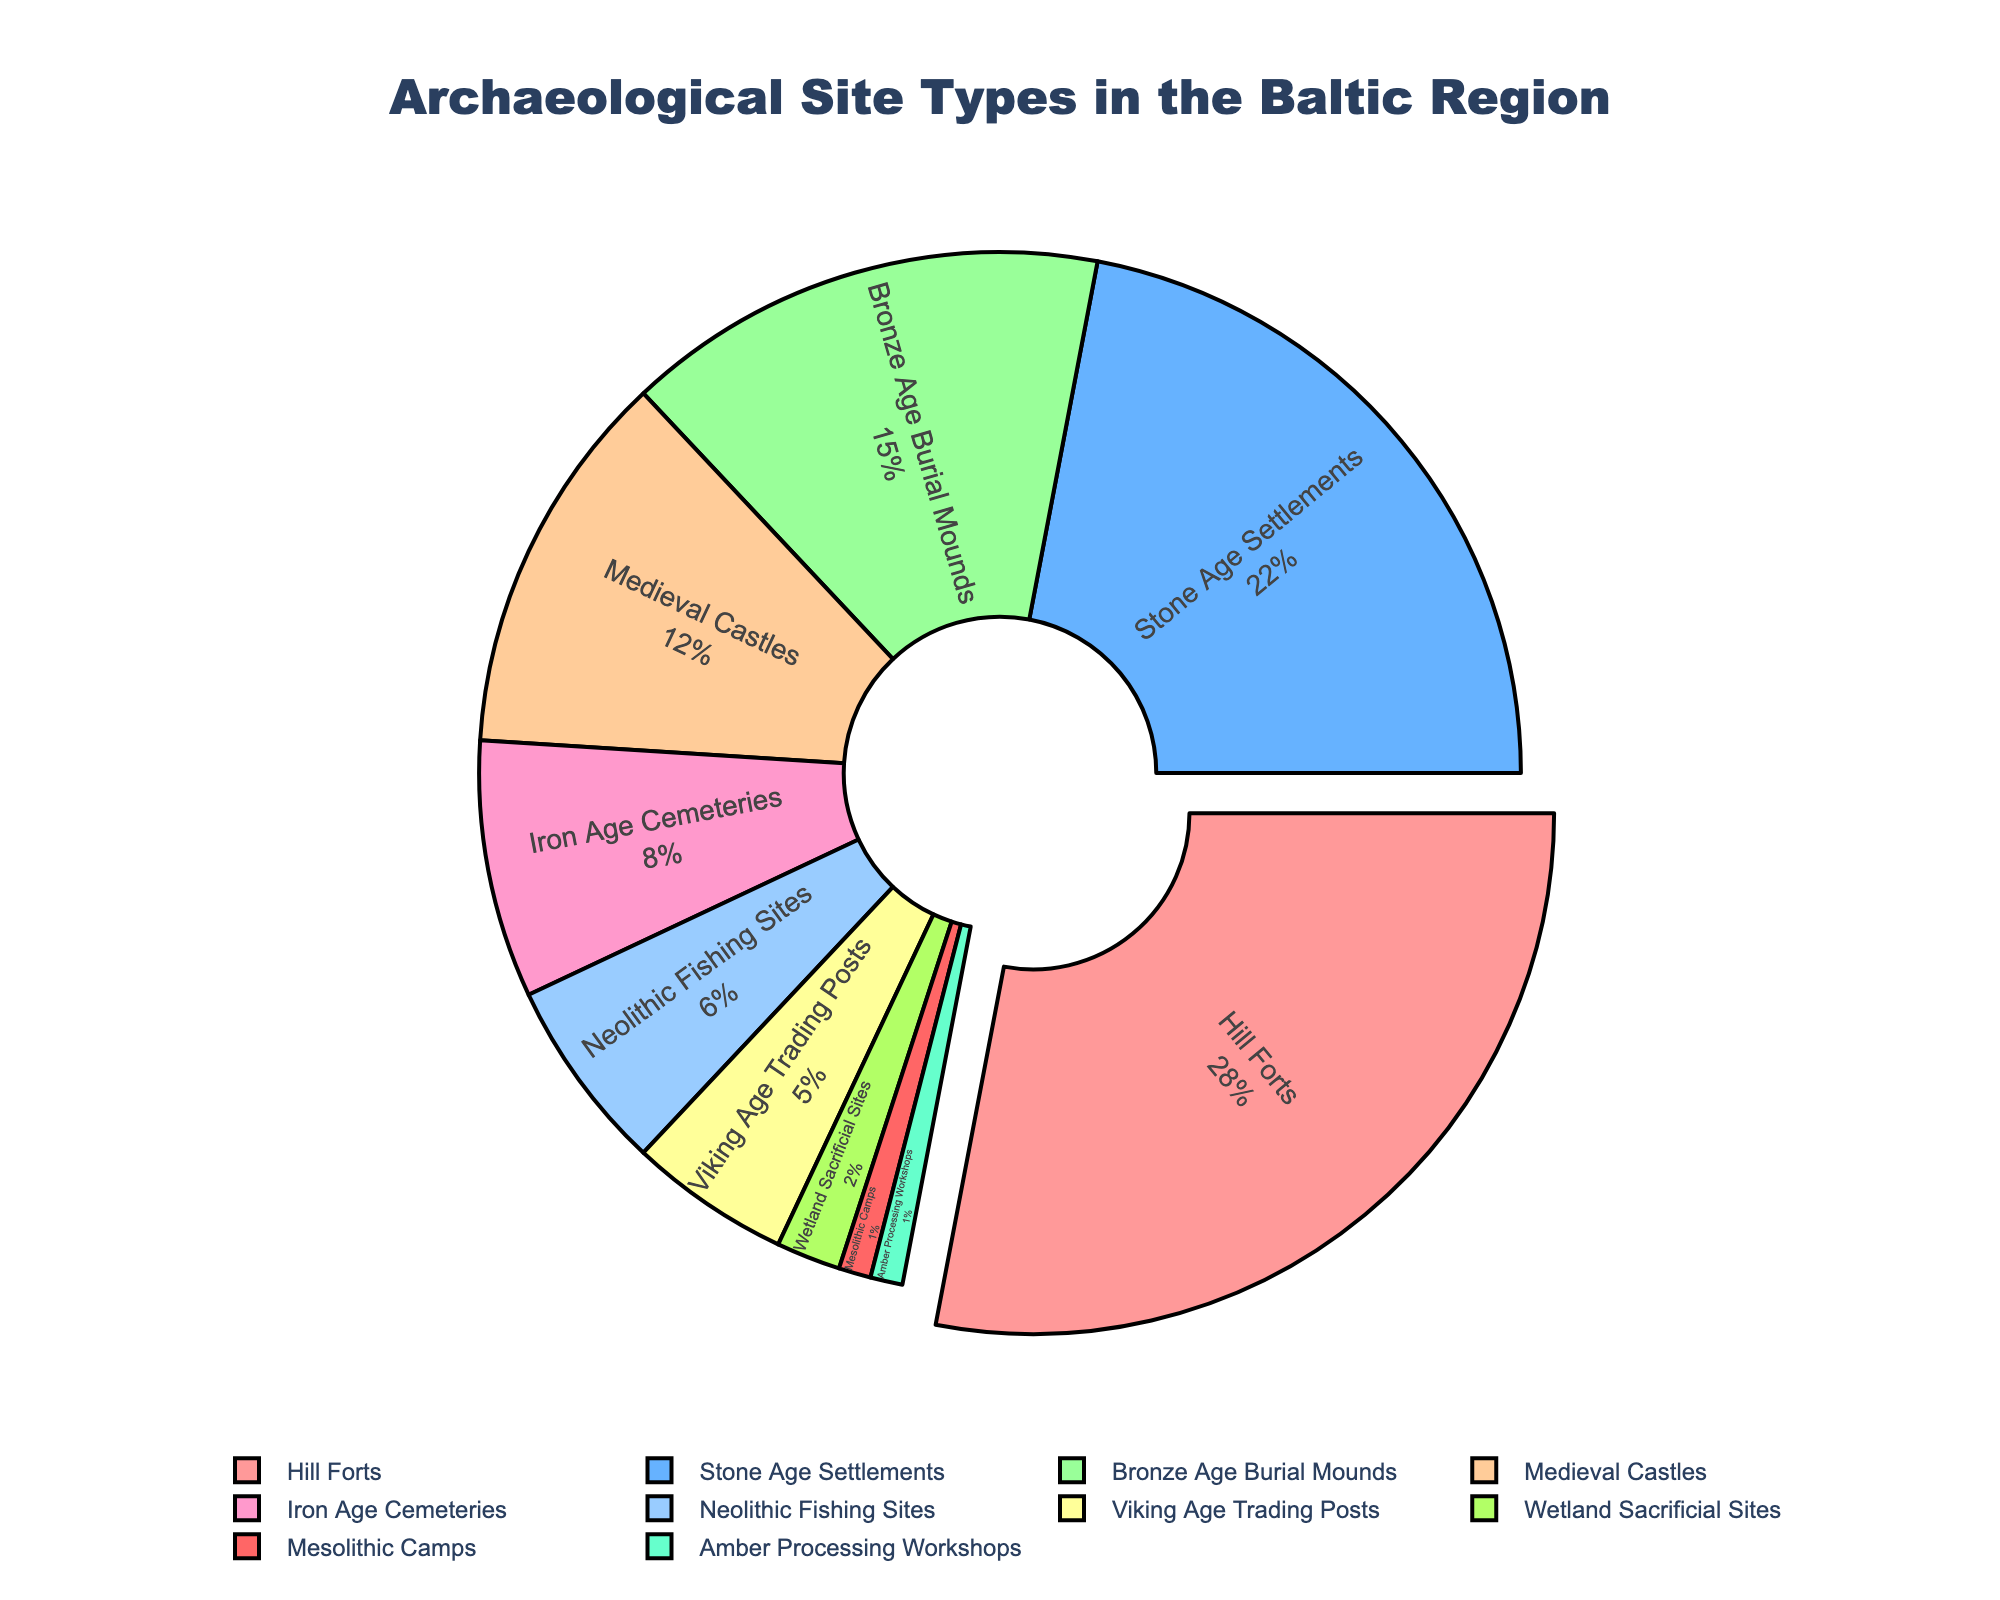What is the percentage of Hill Forts among all archaeological site types? The title of the figure indicates it shows archaeological site types in the Baltic region with percentages labeled for each type. Hill Forts have a percentage of 28% as indicated in the pie chart.
Answer: 28% Which archaeological site type has the smallest percentage? To find the site type with the smallest percentage, look at the segment with the smallest portion in the pie chart. Mesolithic Camps and Amber Processing Workshops both have the smallest percentages, each occupying 1% of the pie.
Answer: Mesolithic Camps and Amber Processing Workshops Are Medieval Castles more common than Iron Age Cemeteries in the Baltic region? By comparing the percentages of Medieval Castles (12%) and Iron Age Cemeteries (8%) in the pie chart, we can see that 12% is greater than 8%, indicating that Medieval Castles are more common.
Answer: Yes What's the combined percentage of Stone Age Settlements and Bronze Age Burial Mounds? Sum the percentages of Stone Age Settlements (22%) and Bronze Age Burial Mounds (15%) shown in the pie chart: 22% + 15% = 37%.
Answer: 37% Are there more Neolithic Fishing Sites or Viking Age Trading Posts in the Baltic region? Compare the percentage values for Neolithic Fishing Sites (6%) and Viking Age Trading Posts (5%) in the pie chart. Since 6% is greater than 5%, there are more Neolithic Fishing Sites.
Answer: Neolithic Fishing Sites What is the total percentage of site types that are related to fortifications or defenses? Sum the percentages of Hill Forts (28%) and Medieval Castles (12%) in the pie chart: 28% + 12% = 40%.
Answer: 40% Which site type has the highest percentage, and what is that percentage? By looking at the visual size of the pie chart segments, Hill Forts stand out as the largest section. The pie chart labels indicate that Hill Forts have the highest percentage of 28%.
Answer: Hill Forts, 28% What color represents Bronze Age Burial Mounds in the pie chart? By identifying the segment for Bronze Age Burial Mounds (15%) and observing its color in the pie chart, one can tell the segment is colored in the fourth position from the starting color, which is peach or light orange.
Answer: Peach or light orange Of the top three most common site types, which has the second highest percentage? The top three most common site types are Hill Forts (28%), Stone Age Settlements (22%), and Bronze Age Burial Mounds (15%). The second highest among these is Stone Age Settlements with 22%.
Answer: Stone Age Settlements What portion of the chart is occupied by Wetland Sacrificial Sites? According to the pie chart, Wetland Sacrificial Sites occupy 2% of the chart, which is a very small portion relative to other types.
Answer: 2% 